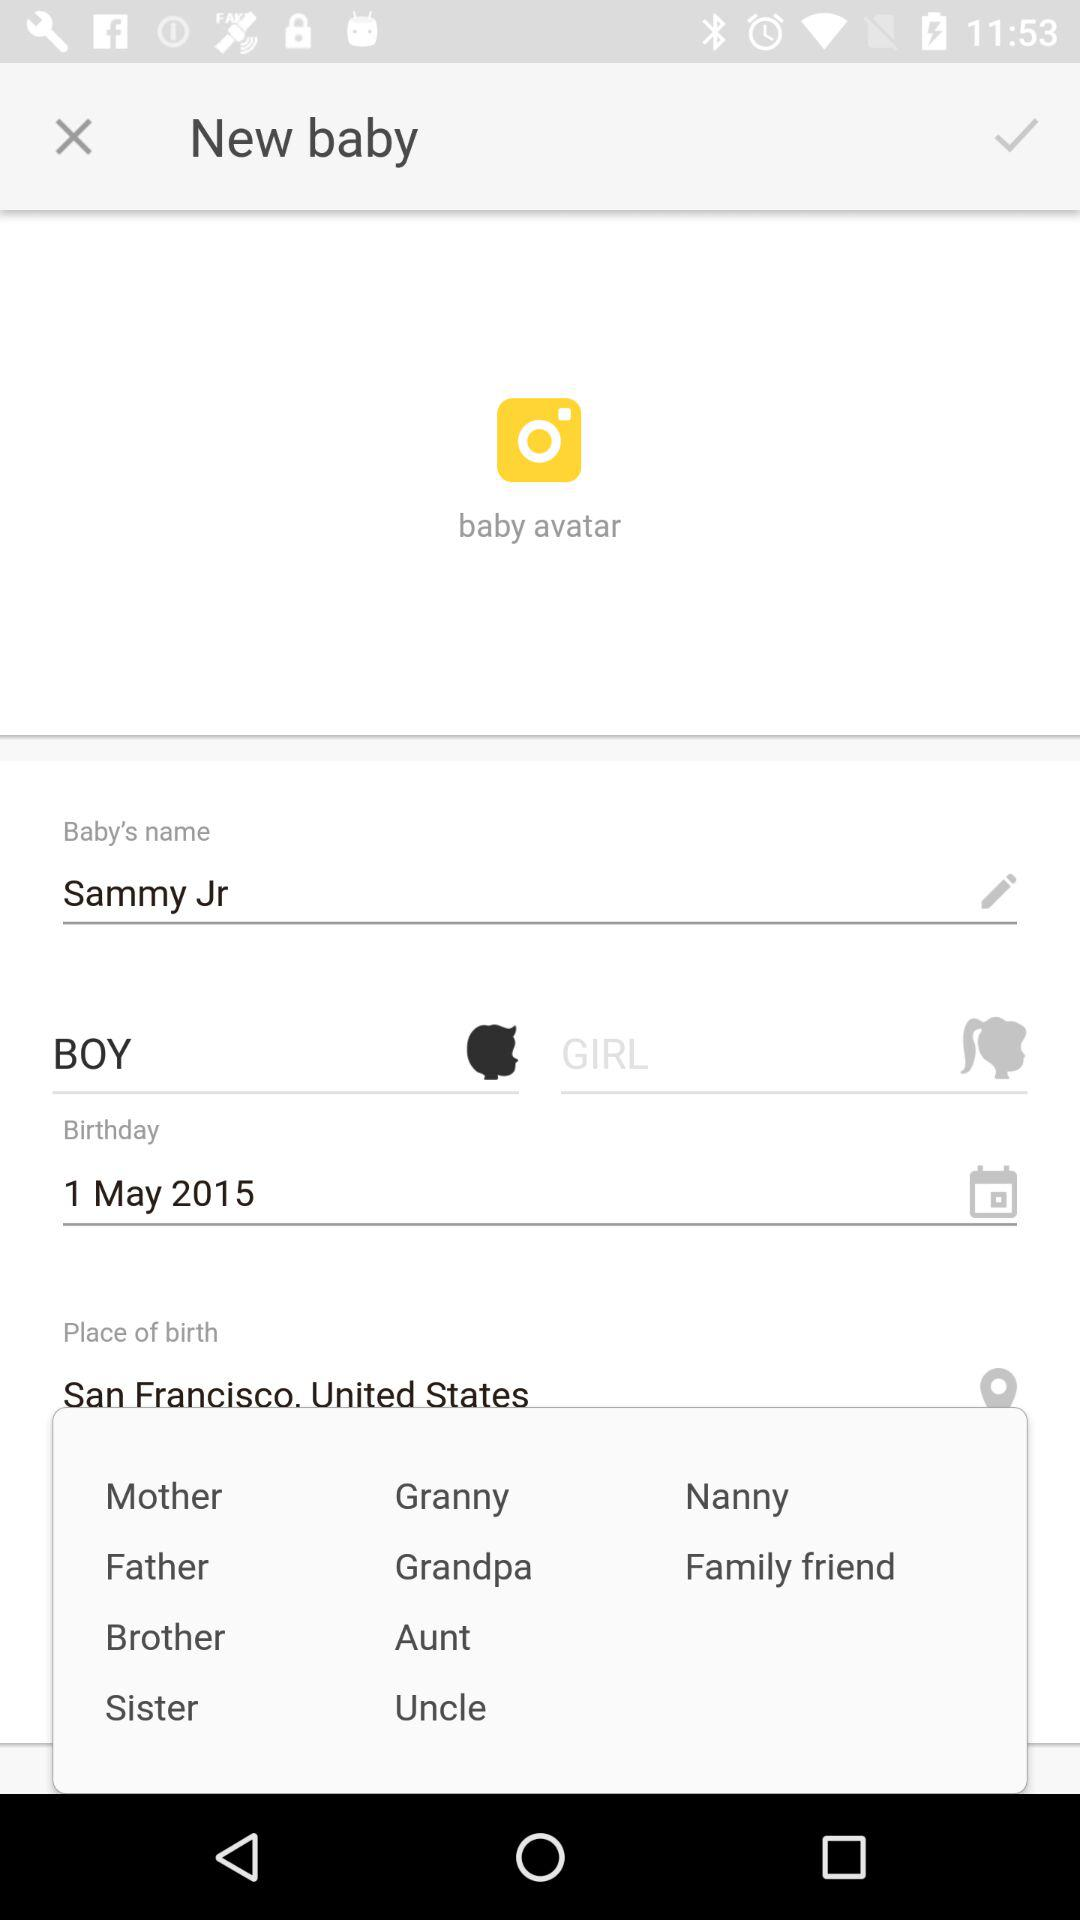What is the place of birth? The place of birth is San Francisco, United States. 